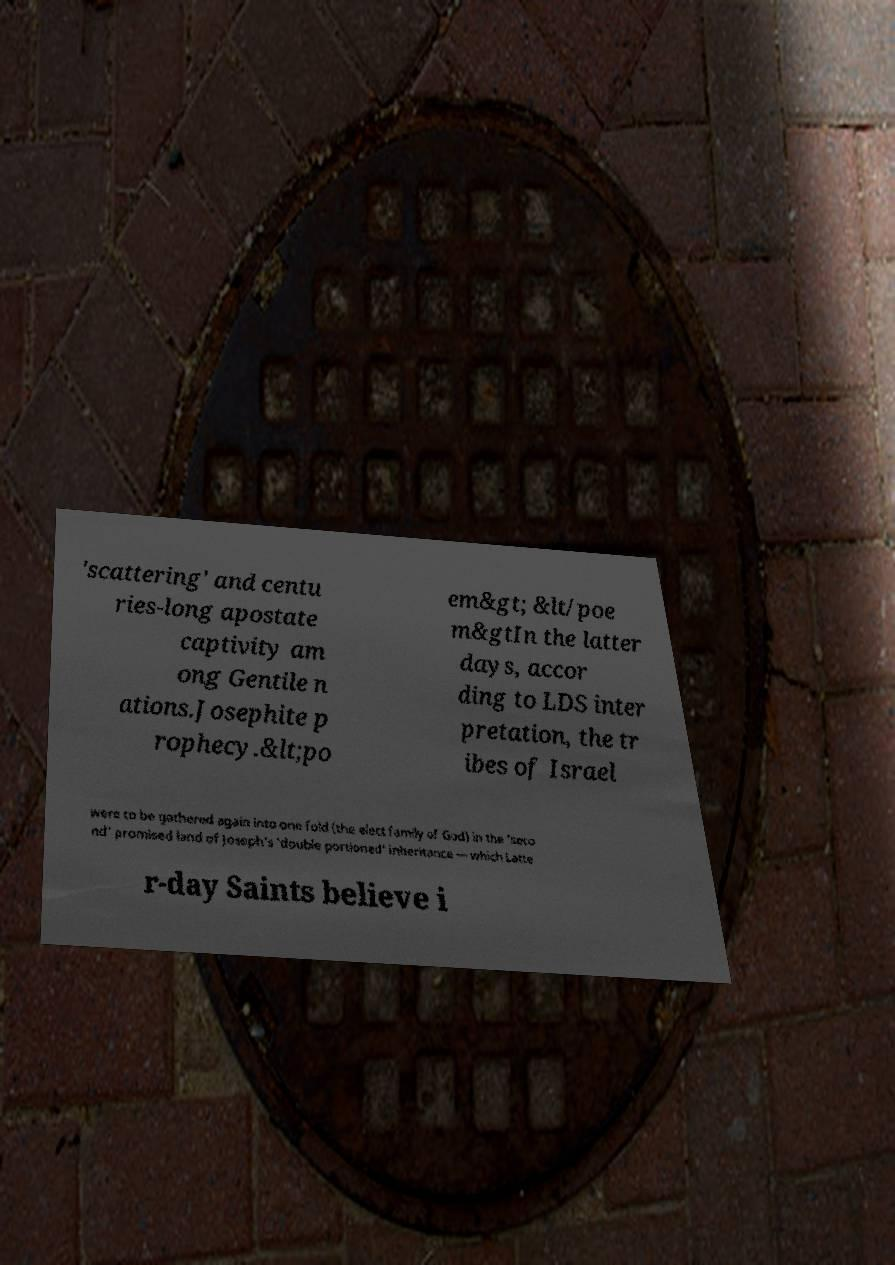Please read and relay the text visible in this image. What does it say? 'scattering' and centu ries-long apostate captivity am ong Gentile n ations.Josephite p rophecy.&lt;po em&gt; &lt/poe m&gtIn the latter days, accor ding to LDS inter pretation, the tr ibes of Israel were to be gathered again into one fold (the elect family of God) in the 'seco nd' promised land of Joseph's 'double portioned' inheritance — which Latte r-day Saints believe i 